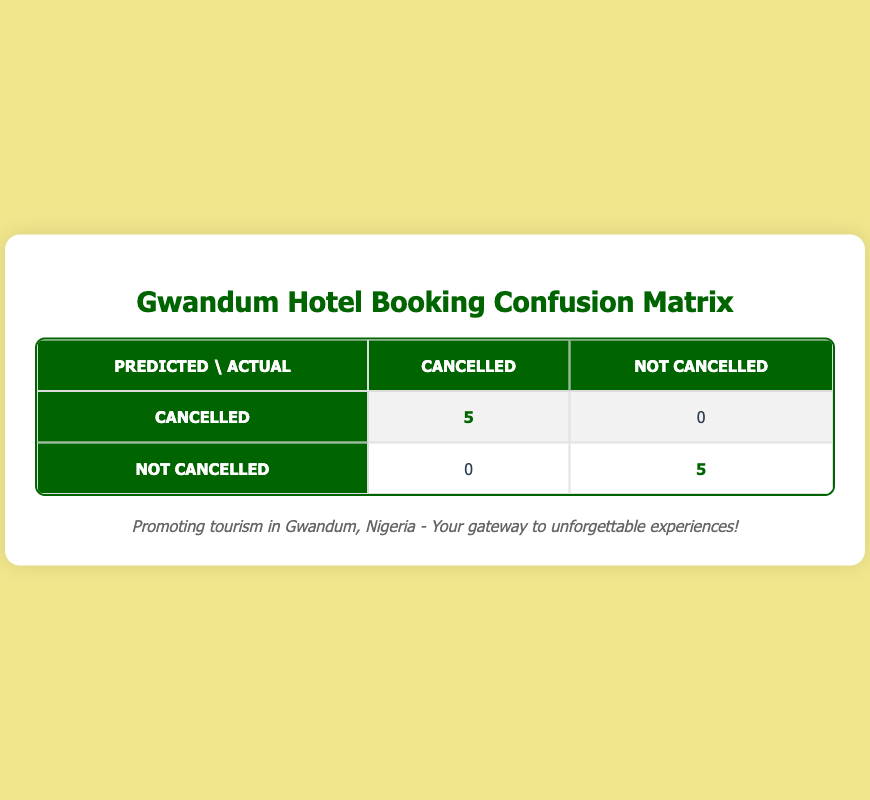What is the total number of bookings that were cancelled? The table indicates that there are 5 bookings where the cancellation status is "Cancelled." This is shown in the highlighted cell under the "Cancelled" row and "Cancelled" column.
Answer: 5 How many bookings were not cancelled? According to the table, there are 5 bookings where the cancellation status is "Not Cancelled." This value is displayed in the highlighted cell under the "Not Cancelled" row and "Not Cancelled" column.
Answer: 5 Is it true that all the predicted cancellations align with the actual cancellations? Yes, the highlighted value indicates that there were 5 instances of predicted cancellations that match the actual cancellations, and no predicted cancellations were incorrect, which confirms the alignment.
Answer: Yes What is the ratio of cancelled bookings to not cancelled bookings? The ratio of cancelled bookings (5) to not cancelled bookings (5) can be calculated as 5:5, which simplifies to 1:1. This indicates an equal number of both types of bookings.
Answer: 1:1 If there were 5 cancelled bookings, how many of them provide specific reasons? All 5 cancelled bookings have specific reasons given as follows: Change of plans, Health issues, Unexpected travel restrictions, Work commitments, and Financial issues. Therefore, all of them provide specific reasons.
Answer: 5 How many bookings were predicted as not cancelled that were actually not cancelled? The table shows that there are 5 bookings that were predicted as not cancelled and were indeed not cancelled. This information is evident in the highlighted cell under the "Not Cancelled" row and "Not Cancelled" column.
Answer: 5 What percentage of total bookings is represented by the cancelled bookings? There are 10 total bookings (5 cancelled and 5 not cancelled). The percentage of cancelled bookings is calculated as (5 cancelled / 10 total) * 100 = 50%.
Answer: 50% Are there any missed predictions for cancelled bookings? No, the table indicates that all 5 actual cancelled bookings were correctly predicted as cancelled, so there are no missed predictions.
Answer: No Compare the actual number of bookings cancelled with those not cancelled. Which is higher? The actual number of cancelled bookings (5) is equal to the number of not cancelled bookings (5), which means neither is higher; they are equal.
Answer: They are equal 